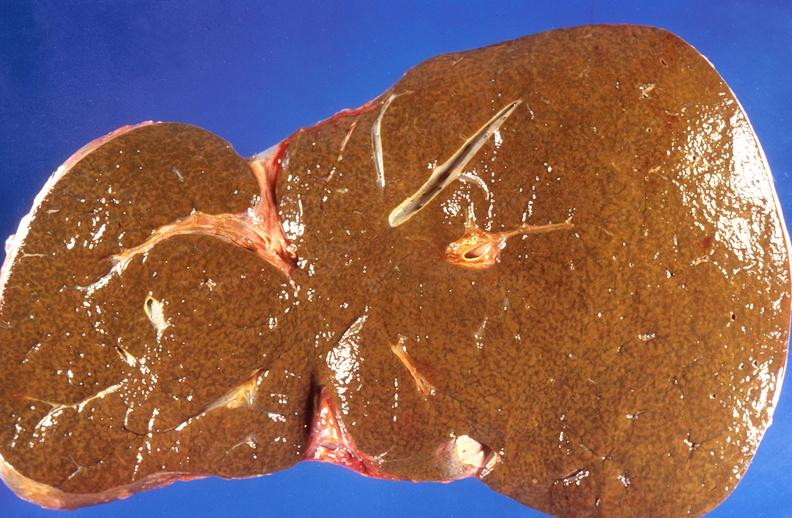does this image show liver, cholestasis and cirrhosis in a patient with cystic fibrosis?
Answer the question using a single word or phrase. Yes 